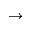<formula> <loc_0><loc_0><loc_500><loc_500>\to</formula> 